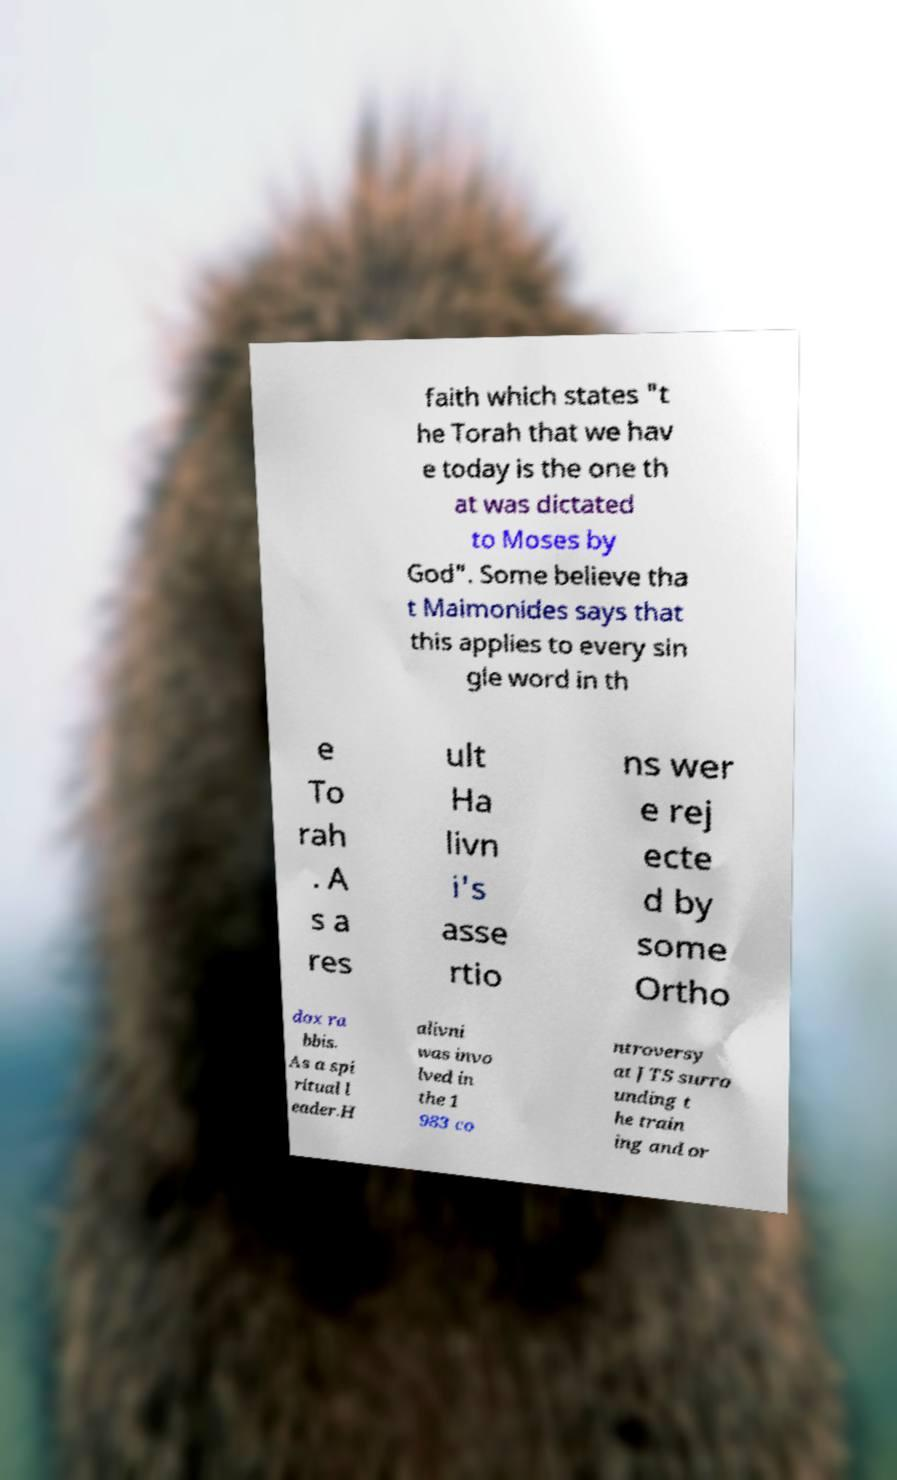Could you extract and type out the text from this image? faith which states "t he Torah that we hav e today is the one th at was dictated to Moses by God". Some believe tha t Maimonides says that this applies to every sin gle word in th e To rah . A s a res ult Ha livn i's asse rtio ns wer e rej ecte d by some Ortho dox ra bbis. As a spi ritual l eader.H alivni was invo lved in the 1 983 co ntroversy at JTS surro unding t he train ing and or 